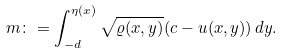<formula> <loc_0><loc_0><loc_500><loc_500>m \colon = \int _ { - d } ^ { \eta ( x ) } \sqrt { \varrho ( x , y ) } ( c - u ( x , y ) ) \, d y .</formula> 